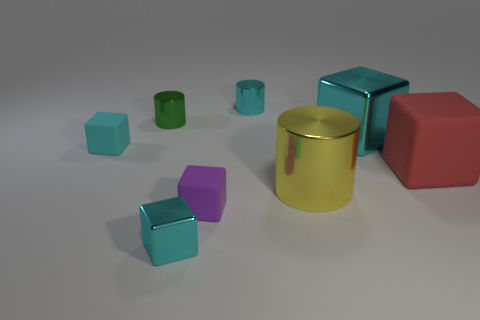How many cyan things are either large shiny cubes or matte cubes?
Keep it short and to the point. 2. What is the shape of the large thing that is behind the small cyan block to the left of the tiny cyan metallic block?
Make the answer very short. Cube. There is a cyan metallic block to the left of the small cyan cylinder; is it the same size as the cyan block that is to the right of the small purple block?
Provide a short and direct response. No. Are there any big purple objects made of the same material as the small cyan cylinder?
Your answer should be compact. No. There is another metal block that is the same color as the small shiny block; what is its size?
Give a very brief answer. Large. There is a metallic block right of the tiny cyan shiny thing that is behind the small cyan rubber block; are there any purple things to the right of it?
Your answer should be very brief. No. There is a purple cube; are there any small matte things right of it?
Make the answer very short. No. There is a tiny metal cylinder on the left side of the small cyan metal cylinder; how many tiny rubber cubes are left of it?
Provide a short and direct response. 1. Is the size of the cyan metallic cylinder the same as the metal cylinder that is in front of the small cyan matte thing?
Offer a terse response. No. Are there any large metallic objects that have the same color as the tiny metallic cube?
Your answer should be compact. Yes. 